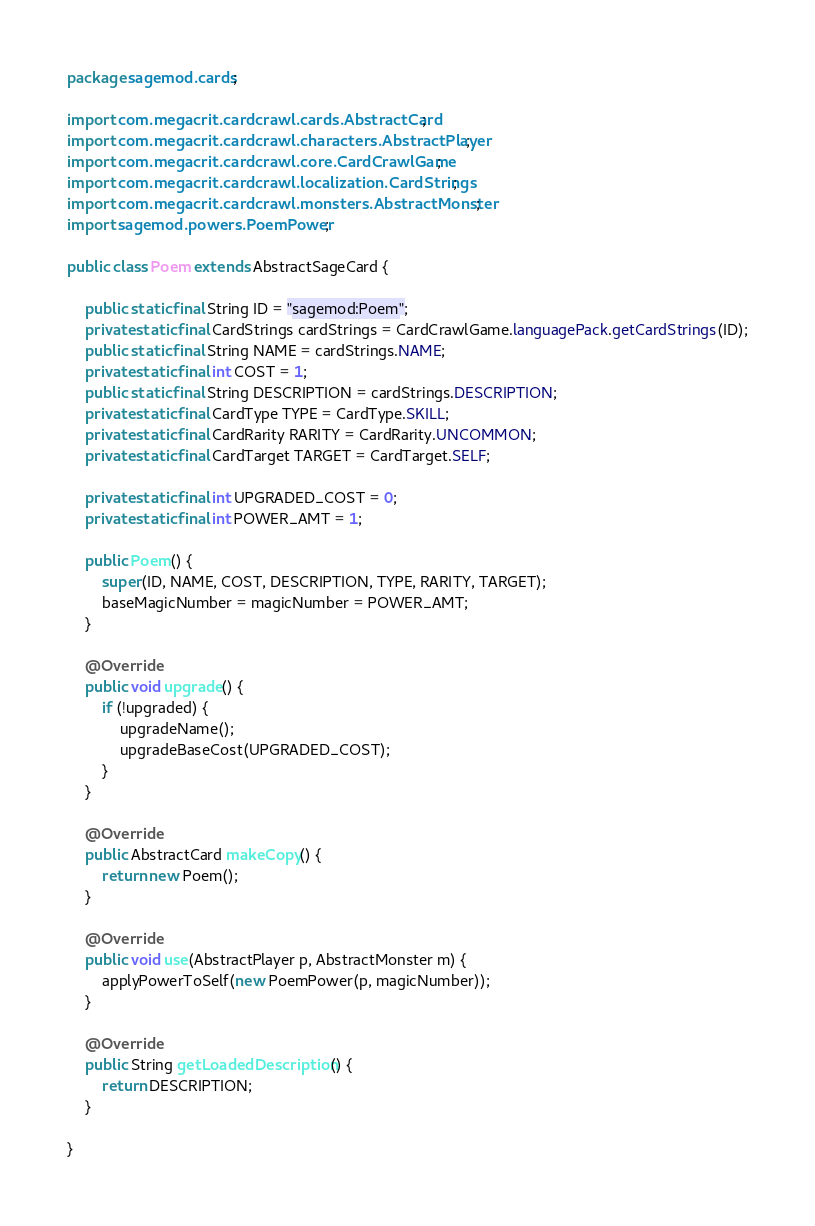Convert code to text. <code><loc_0><loc_0><loc_500><loc_500><_Java_>package sagemod.cards;

import com.megacrit.cardcrawl.cards.AbstractCard;
import com.megacrit.cardcrawl.characters.AbstractPlayer;
import com.megacrit.cardcrawl.core.CardCrawlGame;
import com.megacrit.cardcrawl.localization.CardStrings;
import com.megacrit.cardcrawl.monsters.AbstractMonster;
import sagemod.powers.PoemPower;

public class Poem extends AbstractSageCard {

	public static final String ID = "sagemod:Poem";
	private static final CardStrings cardStrings = CardCrawlGame.languagePack.getCardStrings(ID);
	public static final String NAME = cardStrings.NAME;
	private static final int COST = 1;
	public static final String DESCRIPTION = cardStrings.DESCRIPTION;
	private static final CardType TYPE = CardType.SKILL;
	private static final CardRarity RARITY = CardRarity.UNCOMMON;
	private static final CardTarget TARGET = CardTarget.SELF;

	private static final int UPGRADED_COST = 0;
	private static final int POWER_AMT = 1;

	public Poem() {
		super(ID, NAME, COST, DESCRIPTION, TYPE, RARITY, TARGET);
		baseMagicNumber = magicNumber = POWER_AMT;
	}

	@Override
	public void upgrade() {
		if (!upgraded) {
			upgradeName();
			upgradeBaseCost(UPGRADED_COST);
		}
	}

	@Override
	public AbstractCard makeCopy() {
		return new Poem();
	}

	@Override
	public void use(AbstractPlayer p, AbstractMonster m) {
		applyPowerToSelf(new PoemPower(p, magicNumber));
	}

	@Override
	public String getLoadedDescription() {
		return DESCRIPTION;
	}

}
</code> 